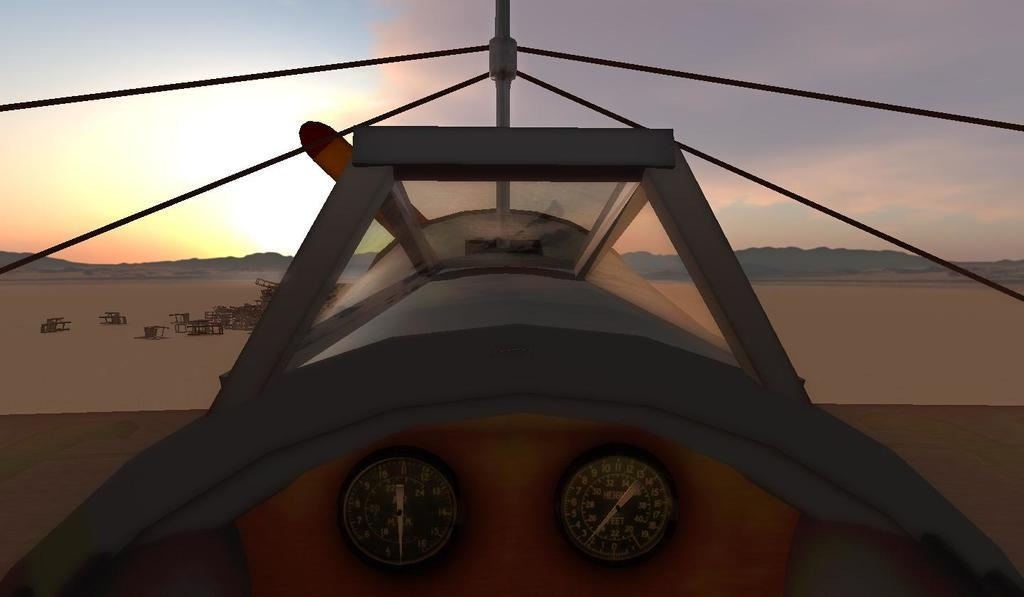<image>
Describe the image concisely. A plane with several numbers and in the middle the word height. 